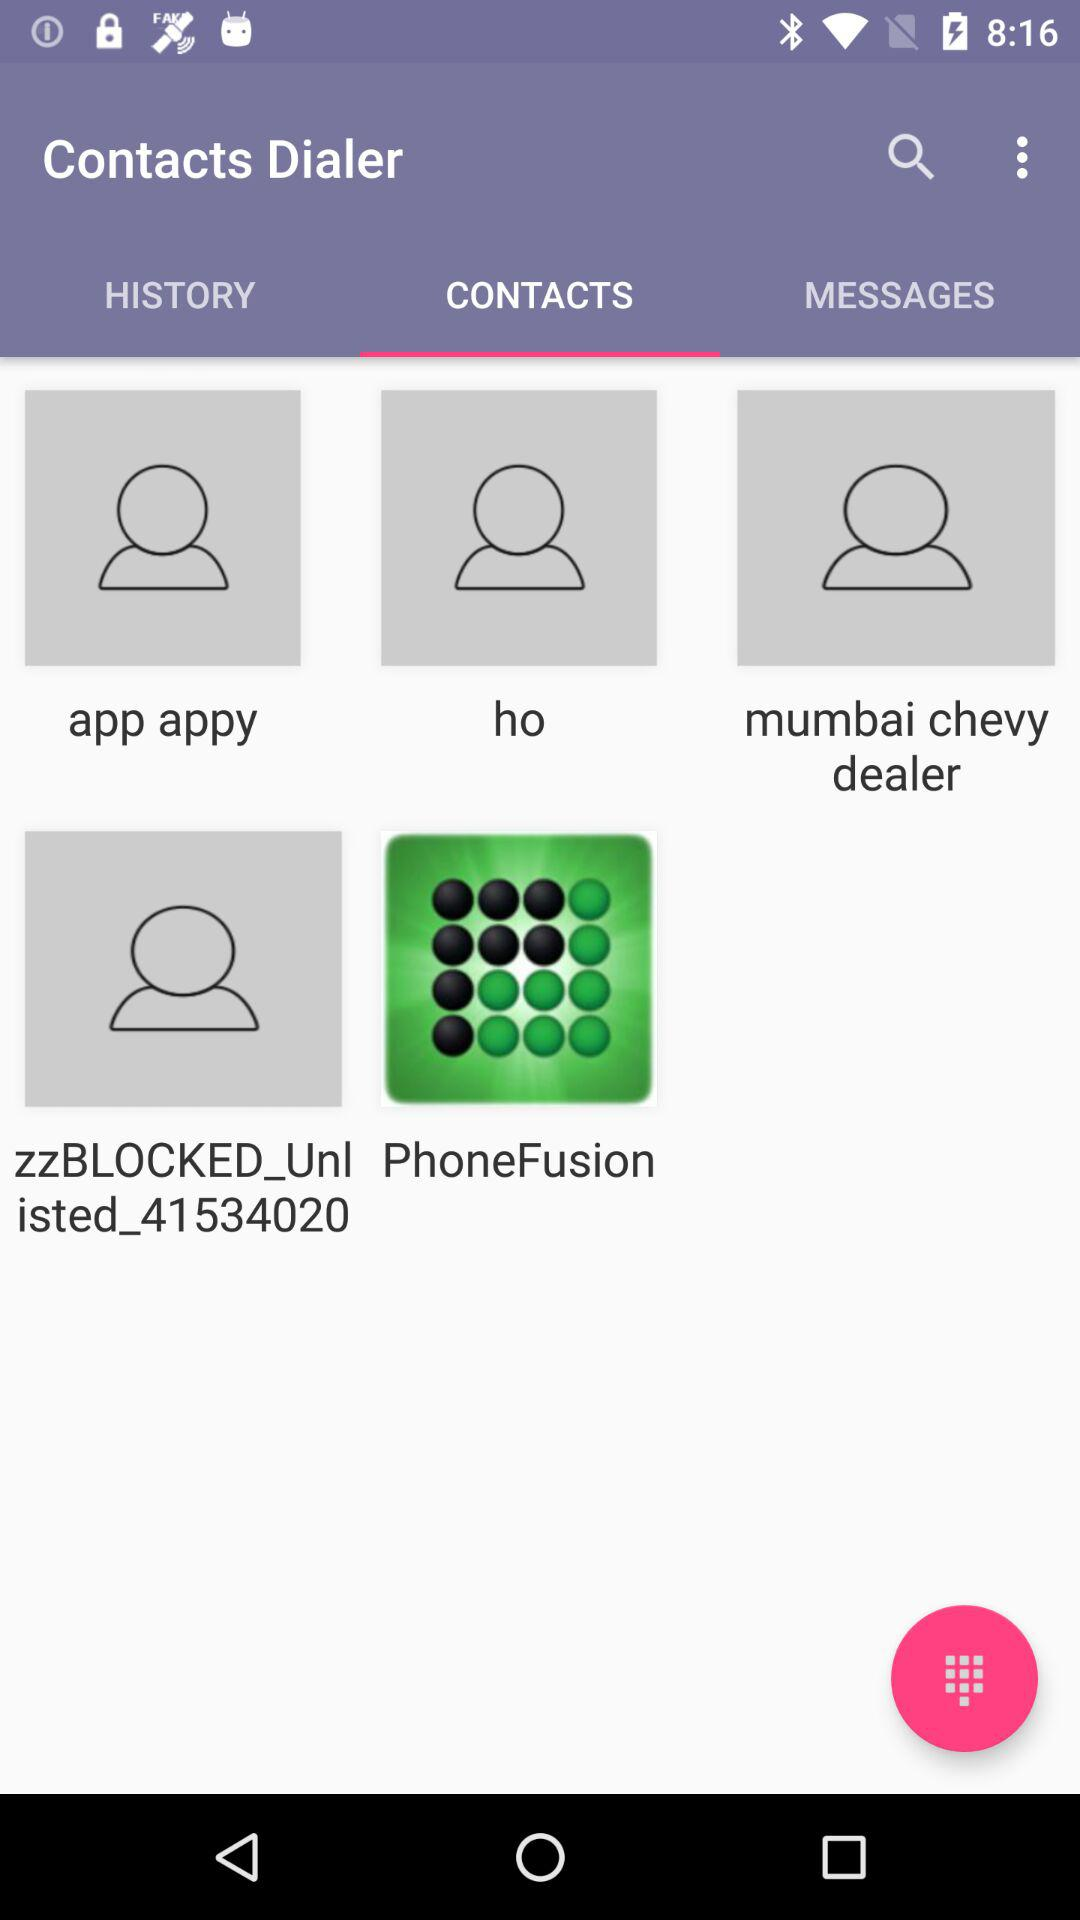Which tab is selected? The selected tab is "CONTACTS". 